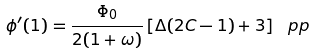<formula> <loc_0><loc_0><loc_500><loc_500>\phi ^ { \prime } ( 1 ) = \frac { \Phi _ { 0 } } { 2 ( 1 + \omega ) } \left [ \Delta ( 2 C - 1 ) + 3 \right ] \ p p</formula> 